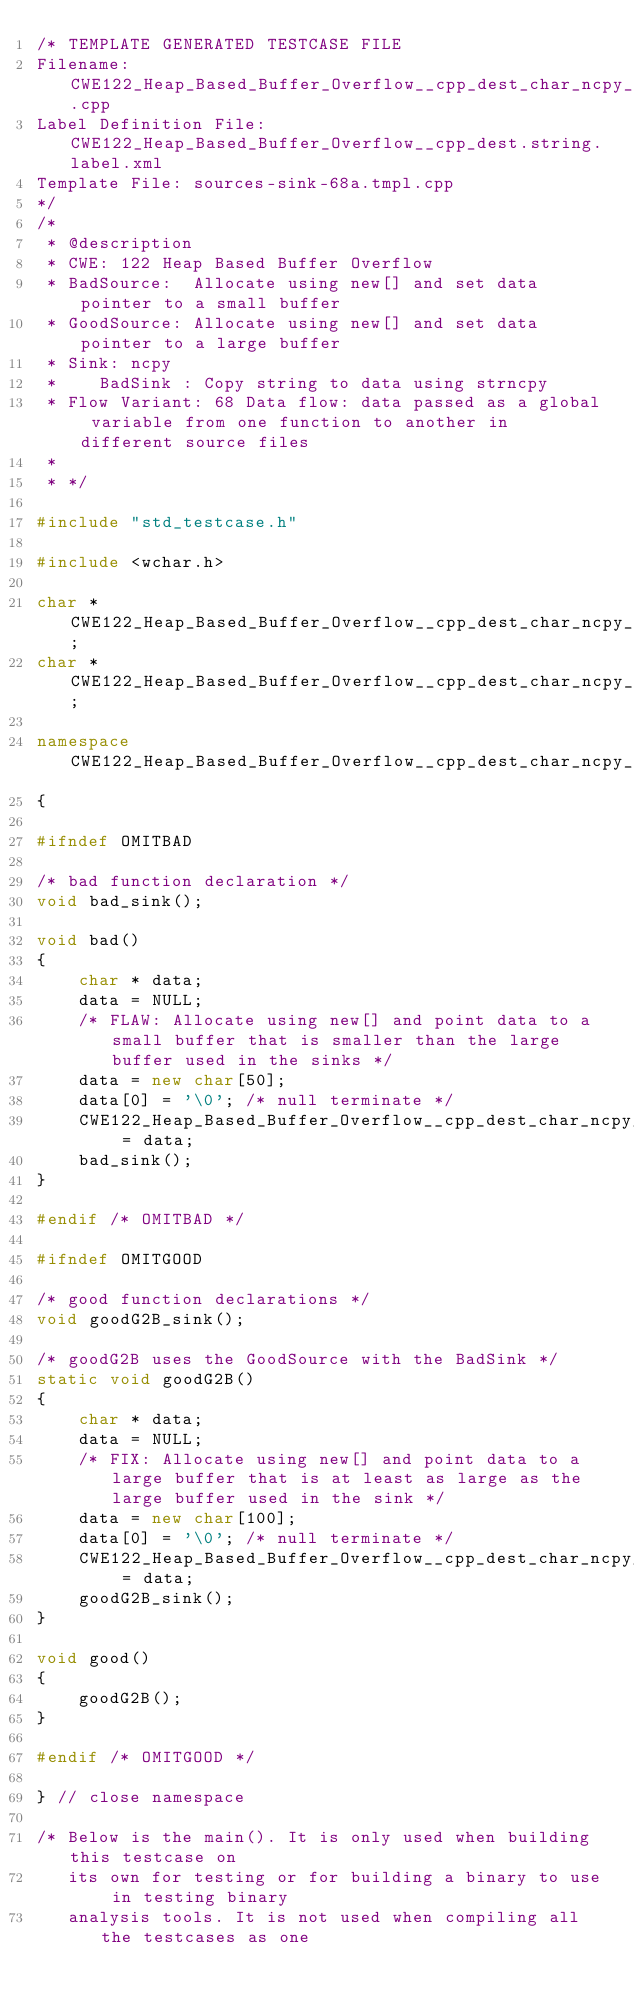Convert code to text. <code><loc_0><loc_0><loc_500><loc_500><_C++_>/* TEMPLATE GENERATED TESTCASE FILE
Filename: CWE122_Heap_Based_Buffer_Overflow__cpp_dest_char_ncpy_68a.cpp
Label Definition File: CWE122_Heap_Based_Buffer_Overflow__cpp_dest.string.label.xml
Template File: sources-sink-68a.tmpl.cpp
*/
/*
 * @description
 * CWE: 122 Heap Based Buffer Overflow
 * BadSource:  Allocate using new[] and set data pointer to a small buffer
 * GoodSource: Allocate using new[] and set data pointer to a large buffer
 * Sink: ncpy
 *    BadSink : Copy string to data using strncpy
 * Flow Variant: 68 Data flow: data passed as a global variable from one function to another in different source files
 *
 * */

#include "std_testcase.h"

#include <wchar.h>

char * CWE122_Heap_Based_Buffer_Overflow__cpp_dest_char_ncpy_68_bad_data;
char * CWE122_Heap_Based_Buffer_Overflow__cpp_dest_char_ncpy_68_goodG2B_data;

namespace CWE122_Heap_Based_Buffer_Overflow__cpp_dest_char_ncpy_68
{

#ifndef OMITBAD

/* bad function declaration */
void bad_sink();

void bad()
{
    char * data;
    data = NULL;
    /* FLAW: Allocate using new[] and point data to a small buffer that is smaller than the large buffer used in the sinks */
    data = new char[50];
    data[0] = '\0'; /* null terminate */
    CWE122_Heap_Based_Buffer_Overflow__cpp_dest_char_ncpy_68_bad_data = data;
    bad_sink();
}

#endif /* OMITBAD */

#ifndef OMITGOOD

/* good function declarations */
void goodG2B_sink();

/* goodG2B uses the GoodSource with the BadSink */
static void goodG2B()
{
    char * data;
    data = NULL;
    /* FIX: Allocate using new[] and point data to a large buffer that is at least as large as the large buffer used in the sink */
    data = new char[100];
    data[0] = '\0'; /* null terminate */
    CWE122_Heap_Based_Buffer_Overflow__cpp_dest_char_ncpy_68_goodG2B_data = data;
    goodG2B_sink();
}

void good()
{
    goodG2B();
}

#endif /* OMITGOOD */

} // close namespace

/* Below is the main(). It is only used when building this testcase on
   its own for testing or for building a binary to use in testing binary
   analysis tools. It is not used when compiling all the testcases as one</code> 